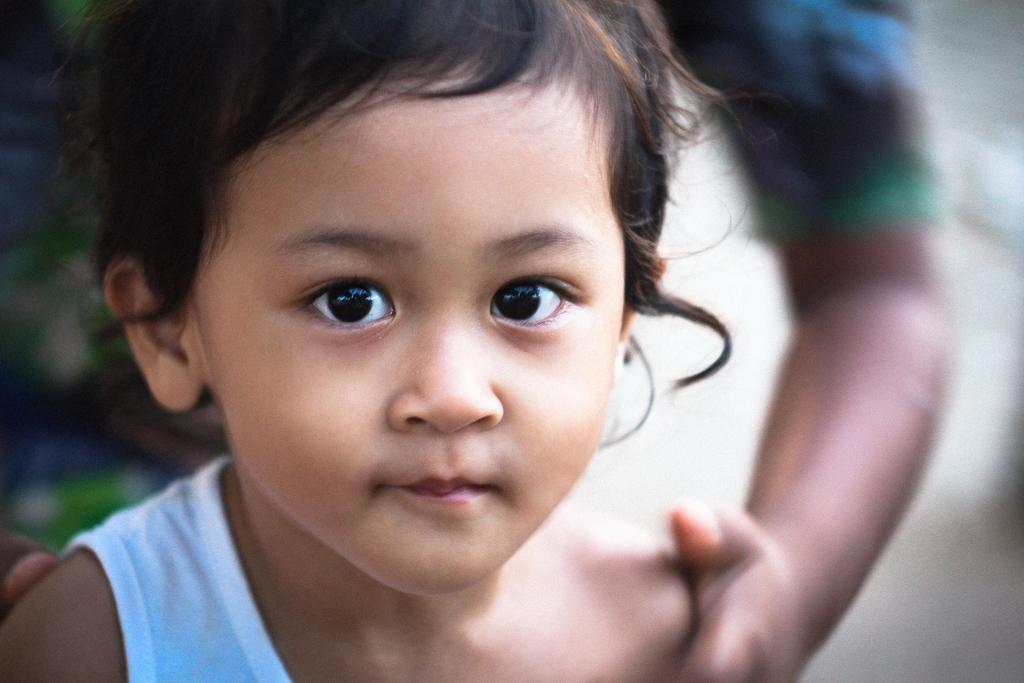What is the main subject of the image? There is a child in the image. Can you describe any other elements in the image? There is a person's hand in the image. What is the color of the background in the image? The background of the image is white in color. What time of day is it in the image, according to the hour hand on the table? There is no clock or hour hand present in the image, so it is not possible to determine the time of day. 